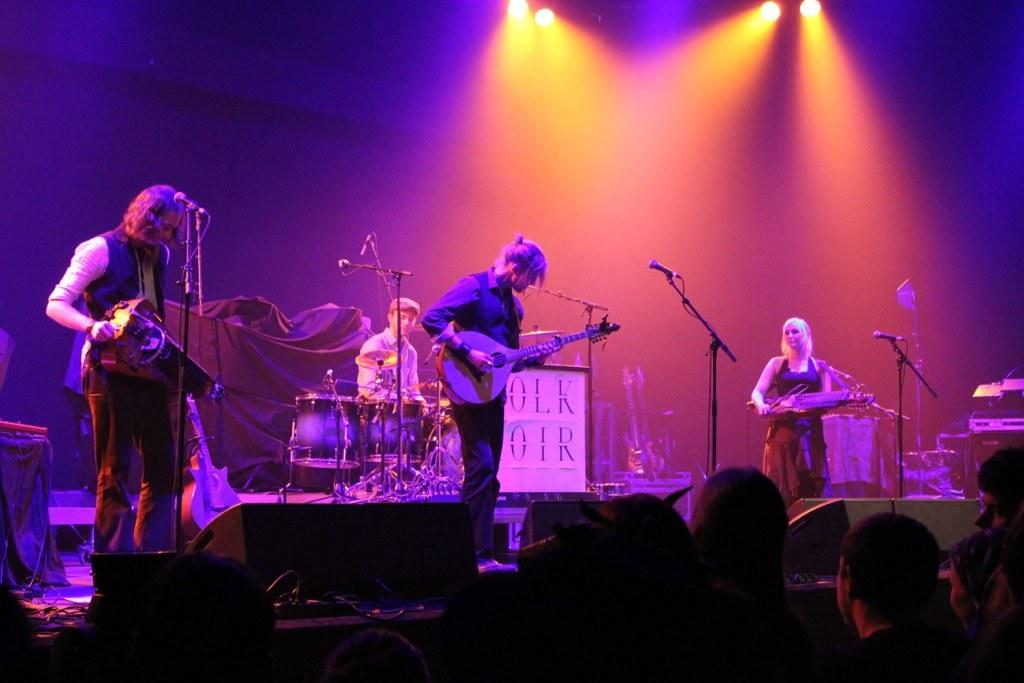What is the main subject of the image? The main subject of the image is a group of people. Can you describe the specific arrangement of the people in the image? Three persons are standing on a stage, and there is a person sitting on a chair in the center back side of the stage. What are the three persons on the stage doing? The three persons on the stage are playing musical instruments. What type of rice can be seen in the image? There is no rice present in the image. Is there a canvas visible in the image? There is no canvas present in the image. 